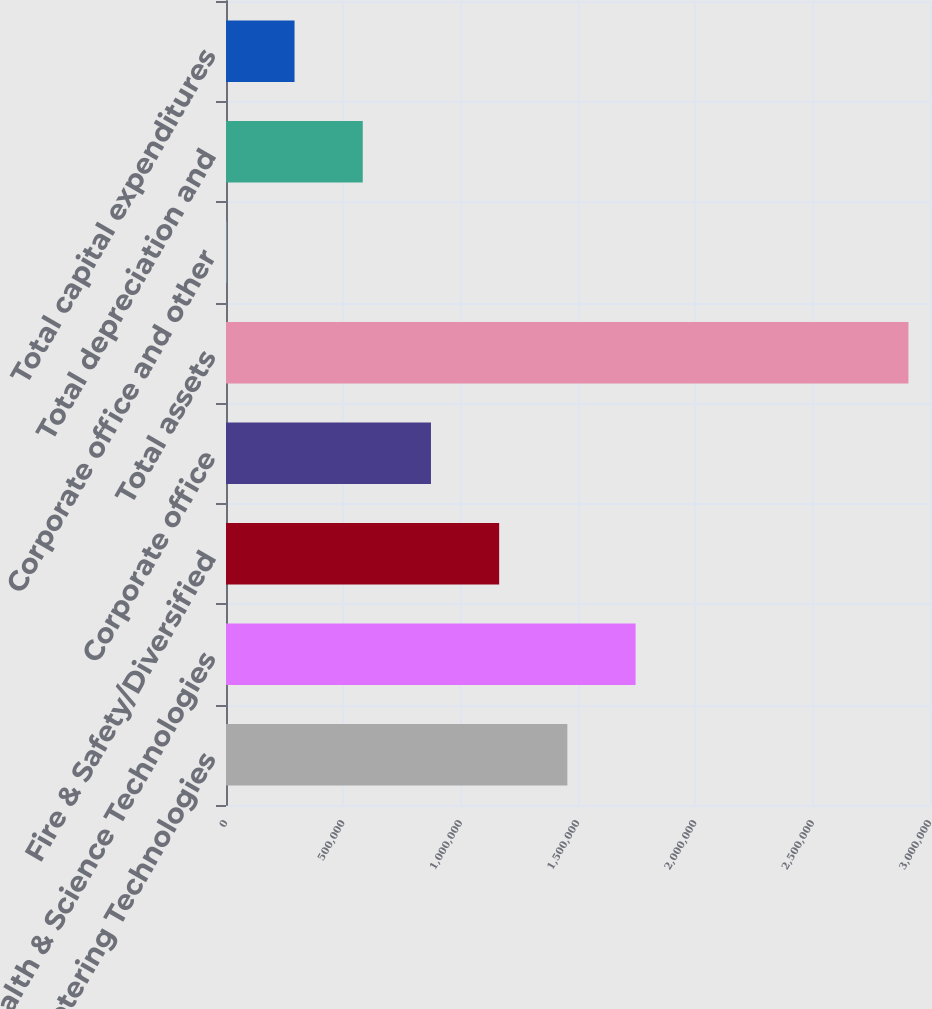Convert chart to OTSL. <chart><loc_0><loc_0><loc_500><loc_500><bar_chart><fcel>Fluid & Metering Technologies<fcel>Health & Science Technologies<fcel>Fire & Safety/Diversified<fcel>Corporate office<fcel>Total assets<fcel>Corporate office and other<fcel>Total depreciation and<fcel>Total capital expenditures<nl><fcel>1.45473e+06<fcel>1.7454e+06<fcel>1.16406e+06<fcel>873396<fcel>2.90807e+06<fcel>1393<fcel>582728<fcel>292061<nl></chart> 